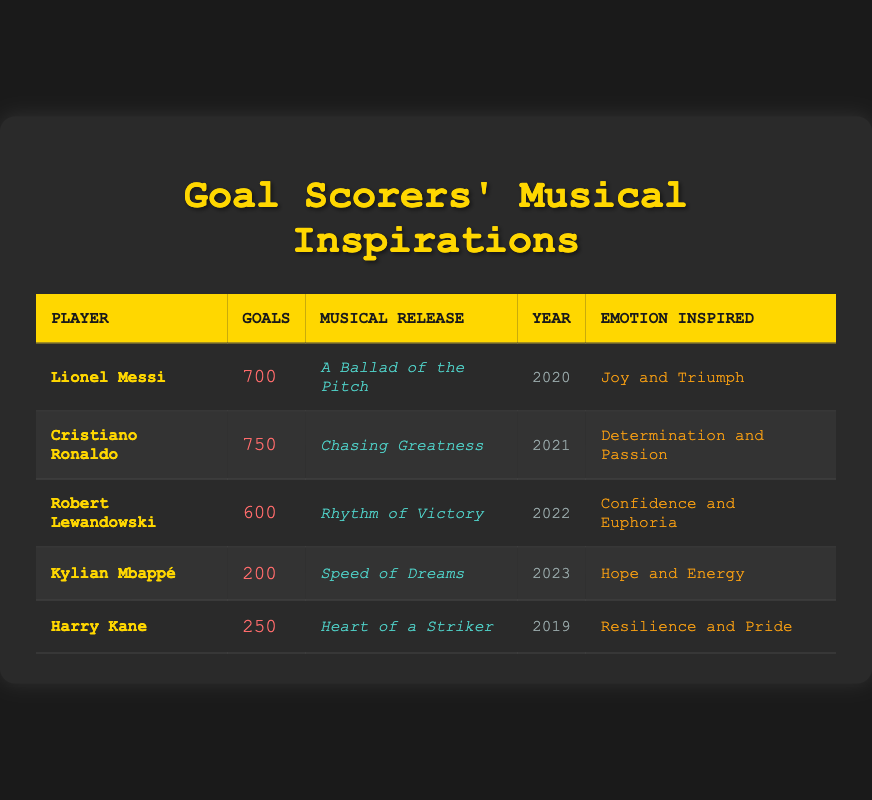What is the total number of goals scored by Cristiano Ronaldo? According to the table, Cristiano Ronaldo has a total of 750 goals listed under the 'Goals' column.
Answer: 750 Which player released their musical piece in 2022? The table shows that Robert Lewandowski is the player who released "Rhythm of Victory" in 2022, as stated in the 'Year' column.
Answer: Robert Lewandowski What emotion is inspired by the musical release "Speed of Dreams"? The table indicates that "Speed of Dreams," released by Kylian Mbappé, is inspired by the emotion of "Hope and Energy" in the 'Emotion Inspired' column.
Answer: Hope and Energy Who has the highest number of total goals and what year was their musical release? The player with the highest total goals is Cristiano Ronaldo with 750 goals. His musical release, "Chasing Greatness," was in 2021, as shown in the respective columns.
Answer: Cristiano Ronaldo, 2021 What is the difference in total goals between Lionel Messi and Harry Kane? To find the difference, subtract Harry Kane's total goals (250) from Lionel Messi's total goals (700), resulting in 700 - 250 = 450.
Answer: 450 Is it true that all players listed have released their music after 2018? Checking the release years provided in the table, we see that Harry Kane's musical release was in 2019. Hence, it is true that all players released their music after 2018.
Answer: Yes What is the average number of total goals scored by the players listed? To find the average, first sum the total goals: 700 + 750 + 600 + 200 + 250 = 2500. Then, divide this sum by the number of players (5), resulting in 2500 / 5 = 500.
Answer: 500 Which player has the musical release that inspires "Resilience and Pride"? According to the table, Harry Kane's musical release, "Heart of a Striker," inspires the emotion "Resilience and Pride," as indicated in the 'Emotion Inspired' column.
Answer: Harry Kane 